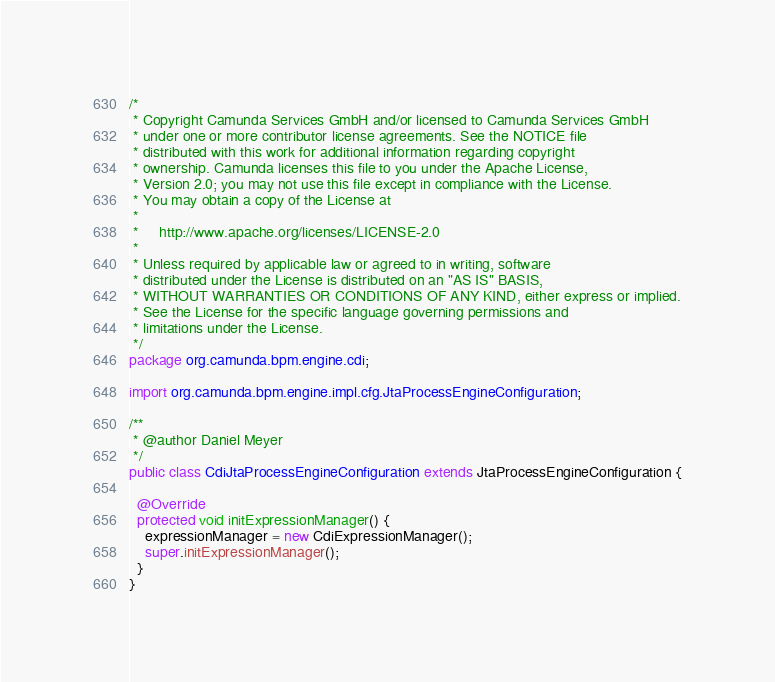Convert code to text. <code><loc_0><loc_0><loc_500><loc_500><_Java_>/*
 * Copyright Camunda Services GmbH and/or licensed to Camunda Services GmbH
 * under one or more contributor license agreements. See the NOTICE file
 * distributed with this work for additional information regarding copyright
 * ownership. Camunda licenses this file to you under the Apache License,
 * Version 2.0; you may not use this file except in compliance with the License.
 * You may obtain a copy of the License at
 *
 *     http://www.apache.org/licenses/LICENSE-2.0
 *
 * Unless required by applicable law or agreed to in writing, software
 * distributed under the License is distributed on an "AS IS" BASIS,
 * WITHOUT WARRANTIES OR CONDITIONS OF ANY KIND, either express or implied.
 * See the License for the specific language governing permissions and
 * limitations under the License.
 */
package org.camunda.bpm.engine.cdi;

import org.camunda.bpm.engine.impl.cfg.JtaProcessEngineConfiguration;

/**
 * @author Daniel Meyer
 */
public class CdiJtaProcessEngineConfiguration extends JtaProcessEngineConfiguration {

  @Override
  protected void initExpressionManager() {
    expressionManager = new CdiExpressionManager();
    super.initExpressionManager();
  }
}
</code> 